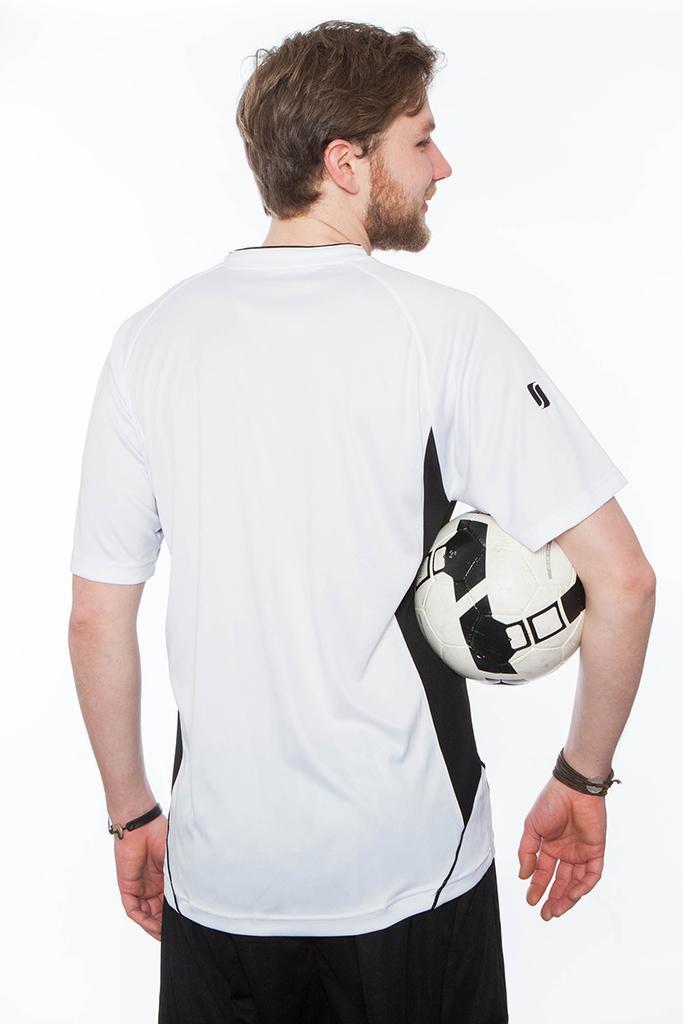Could you give a brief overview of what you see in this image? Here we see a man turning back and holding ball in his hand. 